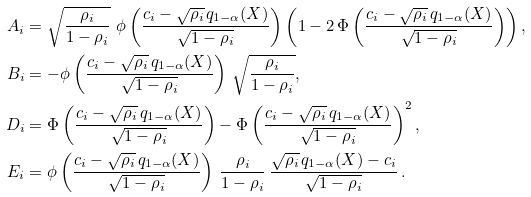<formula> <loc_0><loc_0><loc_500><loc_500>A _ { i } & = \sqrt { \frac { \rho _ { i } } { 1 - \rho _ { i } } } \ \phi \left ( \frac { c _ { i } - \sqrt { \rho _ { i } } \, q _ { 1 - \alpha } ( X ) } { \sqrt { 1 - \rho _ { i } } } \right ) \left ( 1 - 2 \, \Phi \left ( \frac { c _ { i } - \sqrt { \rho _ { i } } \, q _ { 1 - \alpha } ( X ) } { \sqrt { 1 - \rho _ { i } } } \right ) \right ) , \\ B _ { i } & = - \phi \left ( \frac { c _ { i } - \sqrt { \rho _ { i } } \, q _ { 1 - \alpha } ( X ) } { \sqrt { 1 - \rho _ { i } } } \right ) \, \sqrt { \frac { \rho _ { i } } { 1 - \rho _ { i } } } , \\ D _ { i } & = \Phi \left ( \frac { c _ { i } - \sqrt { \rho _ { i } } \, q _ { 1 - \alpha } ( X ) } { \sqrt { 1 - \rho _ { i } } } \right ) - \Phi \left ( \frac { c _ { i } - \sqrt { \rho _ { i } } \, q _ { 1 - \alpha } ( X ) } { \sqrt { 1 - \rho _ { i } } } \right ) ^ { 2 } , \\ E _ { i } & = \phi \left ( \frac { c _ { i } - \sqrt { \rho _ { i } } \, q _ { 1 - \alpha } ( X ) } { \sqrt { 1 - \rho _ { i } } } \right ) \, \frac { \rho _ { i } } { 1 - \rho _ { i } } \, \frac { \sqrt { \rho _ { i } } \, q _ { 1 - \alpha } ( X ) - c _ { i } } { \sqrt { 1 - \rho _ { i } } } \, .</formula> 